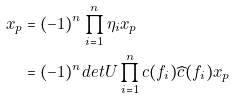<formula> <loc_0><loc_0><loc_500><loc_500>x _ { p } & = ( - 1 ) ^ { n } \prod _ { i = 1 } ^ { n } \eta _ { i } x _ { p } \\ & = ( - 1 ) ^ { n } d e t U \prod _ { i = 1 } ^ { n } c ( f _ { i } ) \widehat { c } ( f _ { i } ) x _ { p }</formula> 